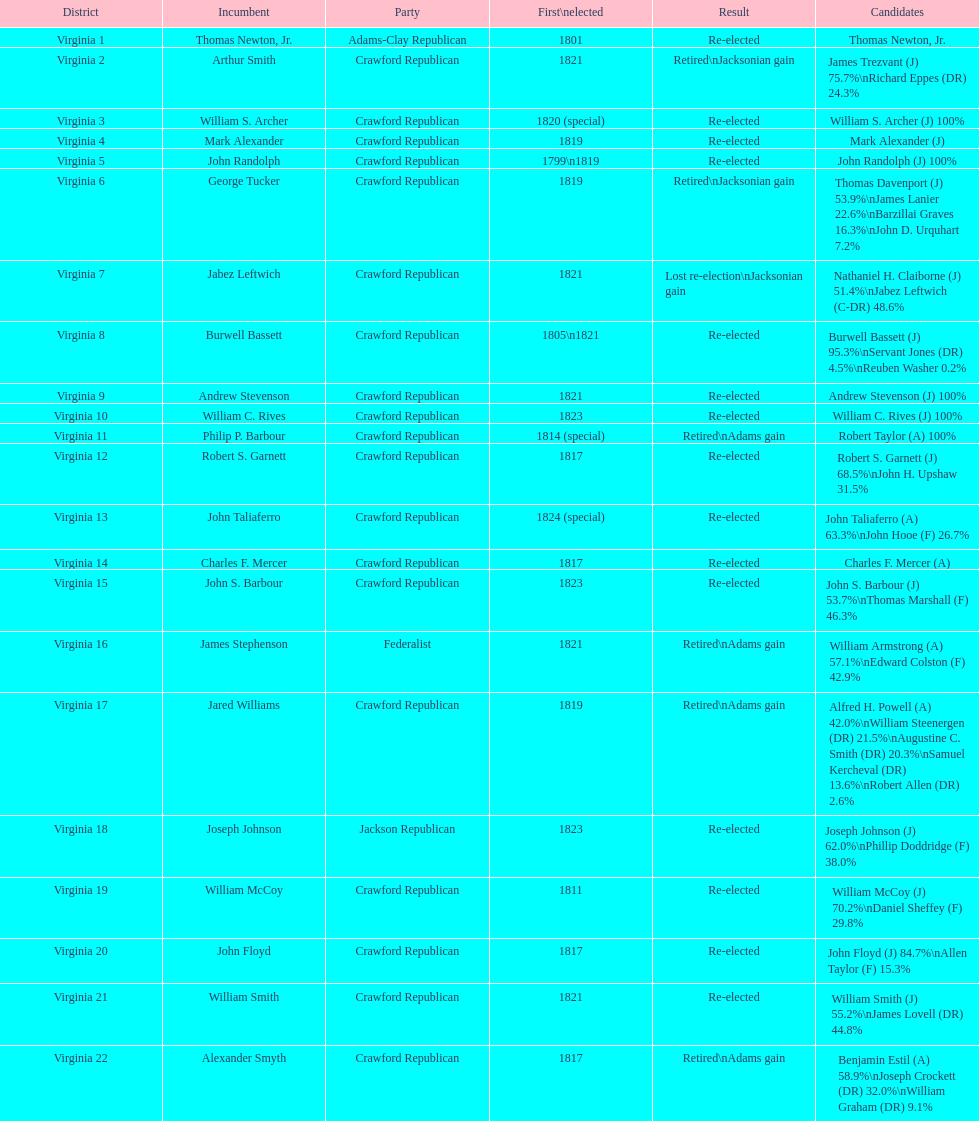How many people were elected for the first time in 1817? 4. 